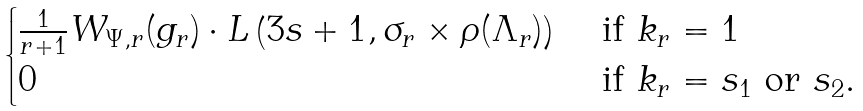Convert formula to latex. <formula><loc_0><loc_0><loc_500><loc_500>\begin{cases} \frac { 1 } { r + 1 } W _ { \Psi , r } ( g _ { r } ) \cdot L \left ( 3 s + 1 , \sigma _ { r } \times \rho ( \Lambda _ { r } ) \right ) & \text { if } k _ { r } = 1 \\ 0 & \text { if } k _ { r } = s _ { 1 } \text { or } s _ { 2 } . \end{cases}</formula> 